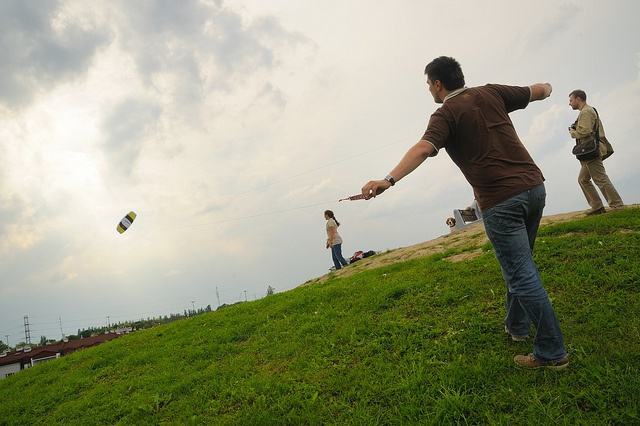Describe the objects in this image and their specific colors. I can see people in darkgray, black, maroon, and gray tones, people in darkgray, gray, and black tones, people in darkgray, black, and gray tones, handbag in darkgray, black, and gray tones, and bench in darkgray, gray, and black tones in this image. 